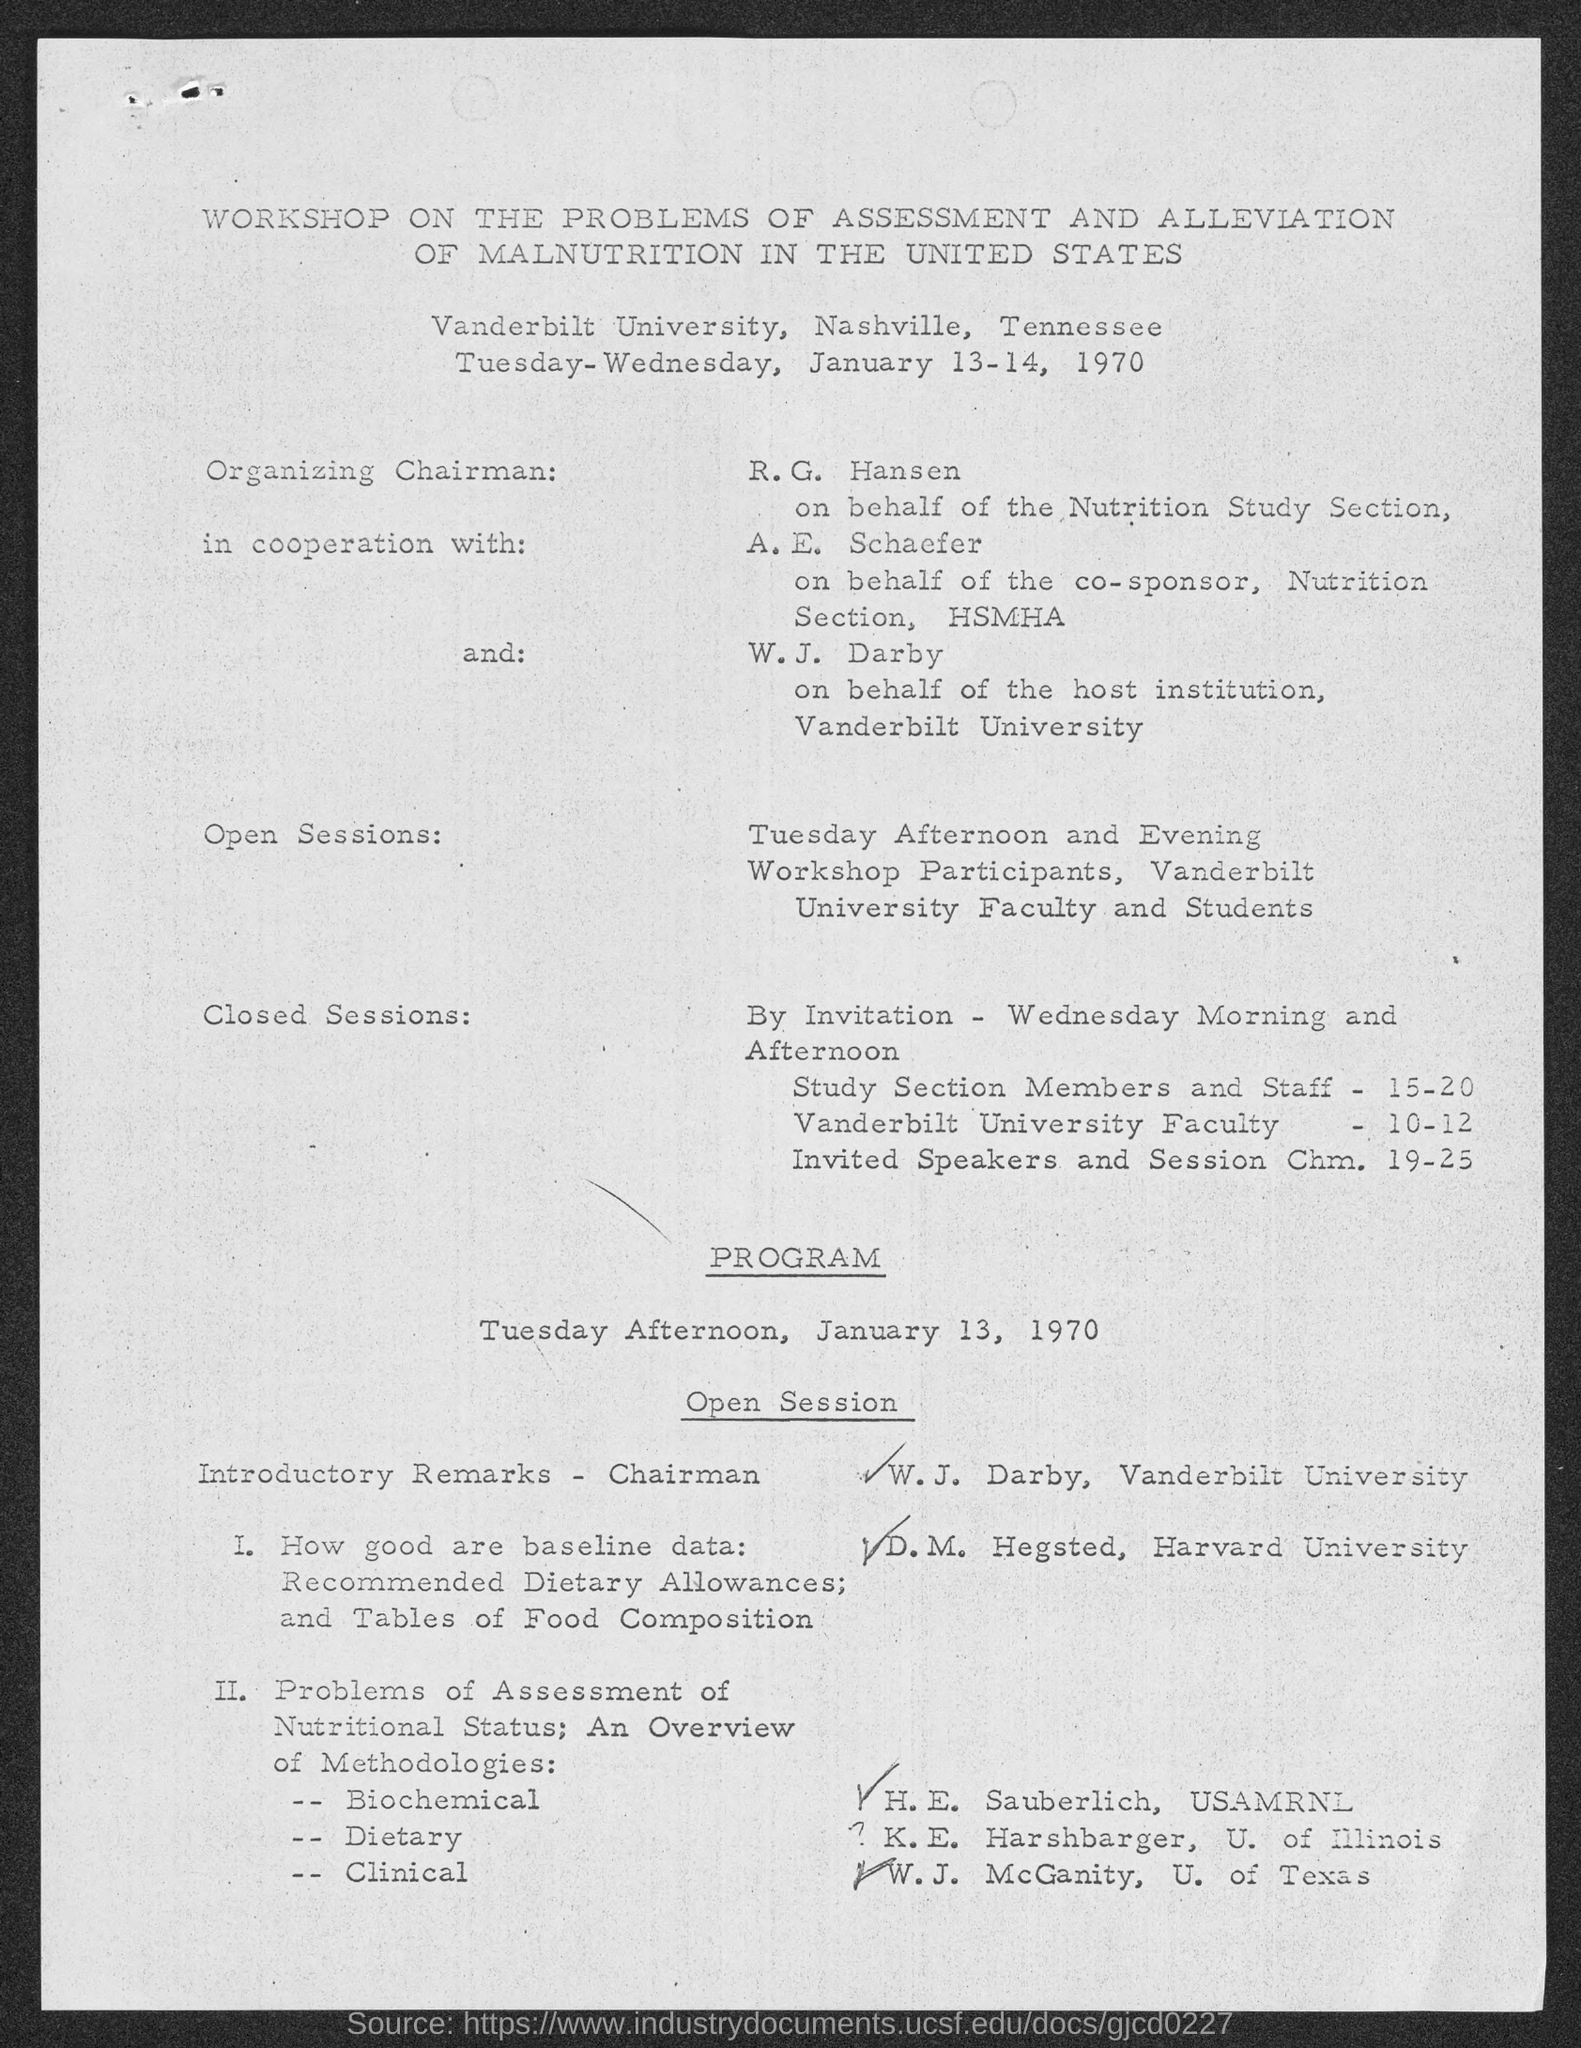Give some essential details in this illustration. The Workshop on the Problems of Assessment and Alleviation of Malnutrition in the United States was held at Vanderbilt University in Nashville, Tennessee. The Workshop on the problems of Assessment and Alleviation of Malnutrition in the United States was held on TUESDAY-WEDNESDAY, JANUARY 13-14, 1970. 